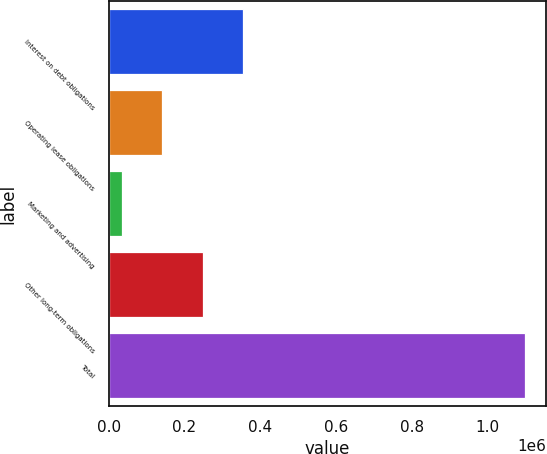Convert chart. <chart><loc_0><loc_0><loc_500><loc_500><bar_chart><fcel>Interest on debt obligations<fcel>Operating lease obligations<fcel>Marketing and advertising<fcel>Other long-term obligations<fcel>Total<nl><fcel>355262<fcel>142312<fcel>35837<fcel>248787<fcel>1.10059e+06<nl></chart> 